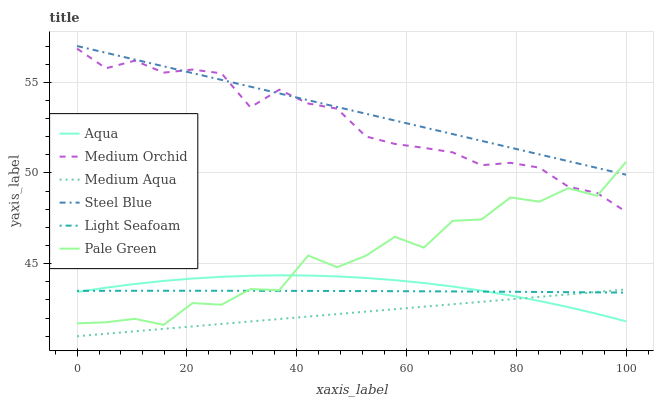Does Medium Aqua have the minimum area under the curve?
Answer yes or no. Yes. Does Steel Blue have the maximum area under the curve?
Answer yes or no. Yes. Does Aqua have the minimum area under the curve?
Answer yes or no. No. Does Aqua have the maximum area under the curve?
Answer yes or no. No. Is Steel Blue the smoothest?
Answer yes or no. Yes. Is Pale Green the roughest?
Answer yes or no. Yes. Is Aqua the smoothest?
Answer yes or no. No. Is Aqua the roughest?
Answer yes or no. No. Does Medium Aqua have the lowest value?
Answer yes or no. Yes. Does Aqua have the lowest value?
Answer yes or no. No. Does Steel Blue have the highest value?
Answer yes or no. Yes. Does Aqua have the highest value?
Answer yes or no. No. Is Medium Aqua less than Steel Blue?
Answer yes or no. Yes. Is Steel Blue greater than Aqua?
Answer yes or no. Yes. Does Aqua intersect Light Seafoam?
Answer yes or no. Yes. Is Aqua less than Light Seafoam?
Answer yes or no. No. Is Aqua greater than Light Seafoam?
Answer yes or no. No. Does Medium Aqua intersect Steel Blue?
Answer yes or no. No. 